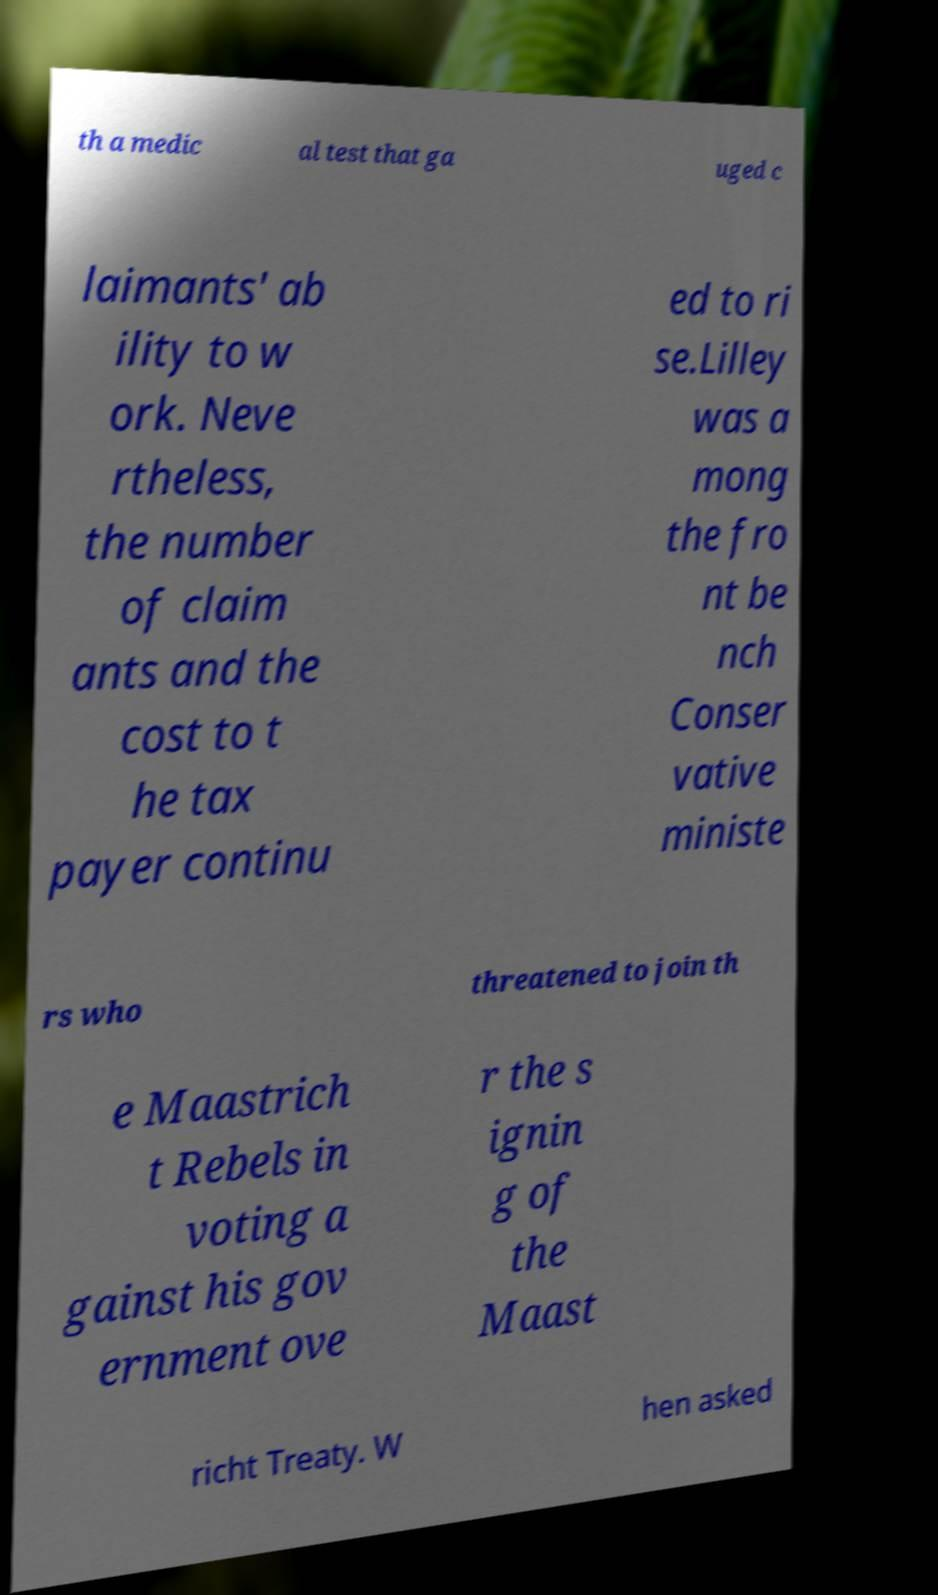I need the written content from this picture converted into text. Can you do that? th a medic al test that ga uged c laimants' ab ility to w ork. Neve rtheless, the number of claim ants and the cost to t he tax payer continu ed to ri se.Lilley was a mong the fro nt be nch Conser vative ministe rs who threatened to join th e Maastrich t Rebels in voting a gainst his gov ernment ove r the s ignin g of the Maast richt Treaty. W hen asked 